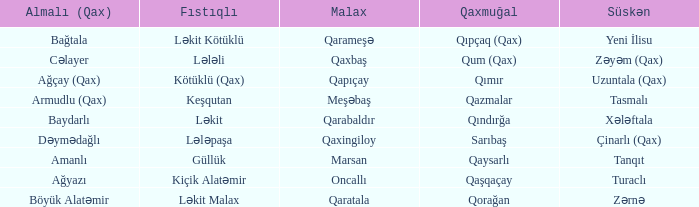What is the Almali village with the Malax village qaxingiloy? Dəymədağlı. 